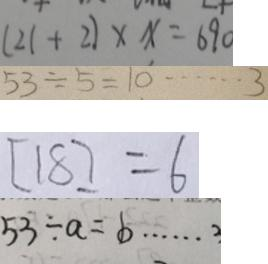Convert formula to latex. <formula><loc_0><loc_0><loc_500><loc_500>( 2 1 + 2 ) \times x = 6 9 0 
 5 3 \div 5 = 1 0 \cdots 3 
 [ 1 8 ] = 6 
 5 3 \div a = b \cdots 3</formula> 